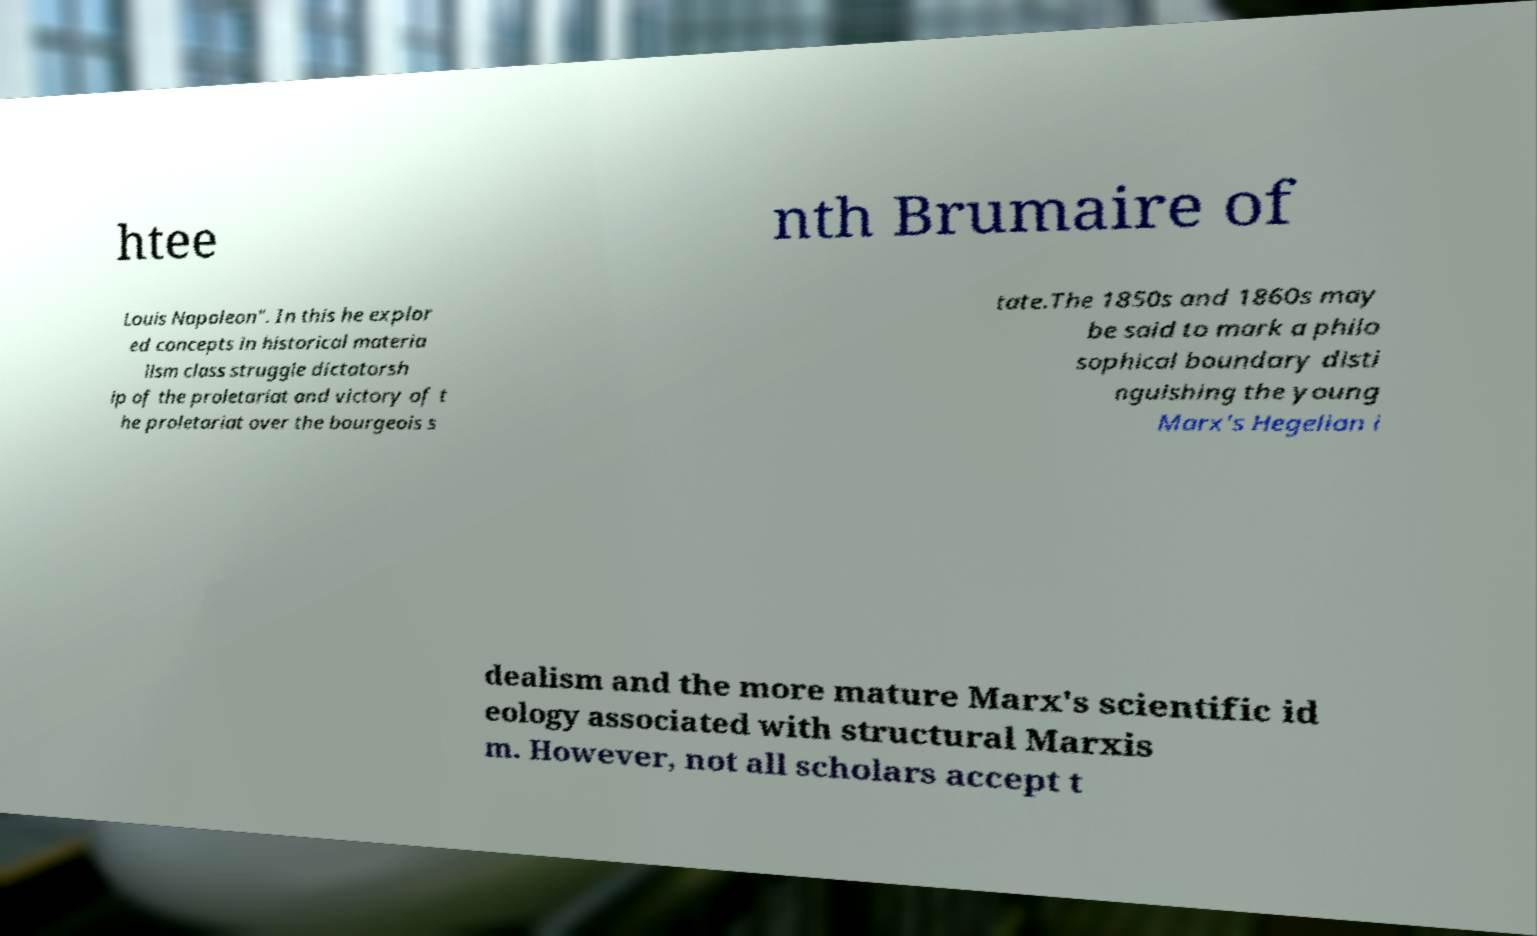Could you assist in decoding the text presented in this image and type it out clearly? htee nth Brumaire of Louis Napoleon". In this he explor ed concepts in historical materia lism class struggle dictatorsh ip of the proletariat and victory of t he proletariat over the bourgeois s tate.The 1850s and 1860s may be said to mark a philo sophical boundary disti nguishing the young Marx's Hegelian i dealism and the more mature Marx's scientific id eology associated with structural Marxis m. However, not all scholars accept t 